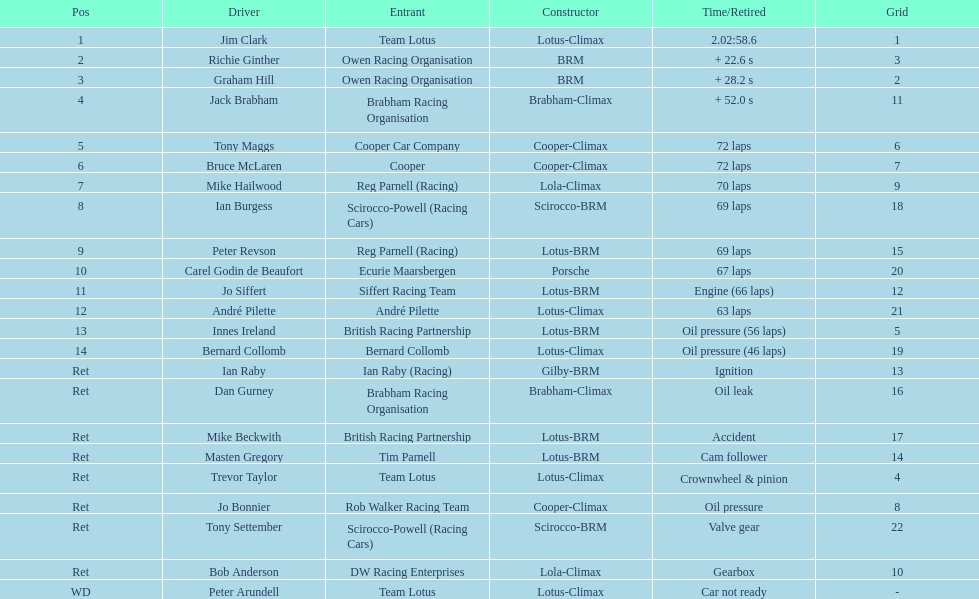How many americans are included in the top 5? 1. 